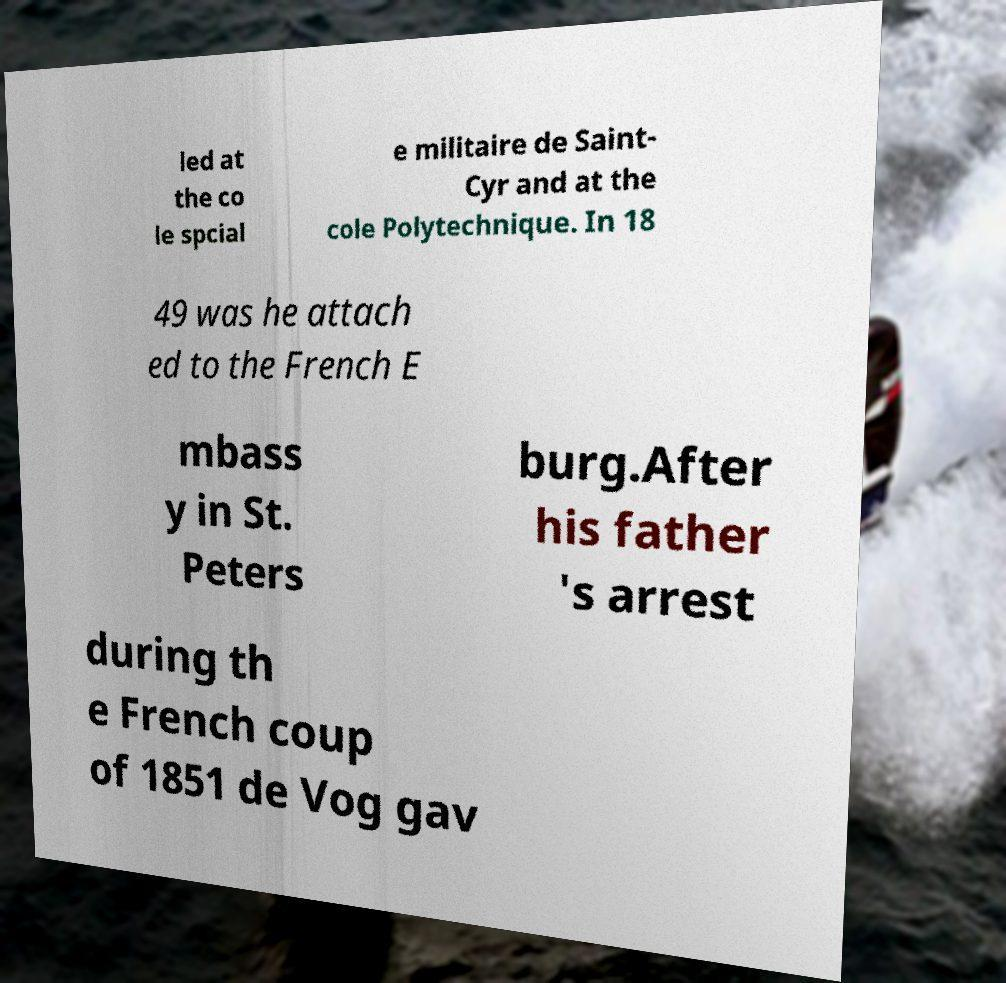Please read and relay the text visible in this image. What does it say? led at the co le spcial e militaire de Saint- Cyr and at the cole Polytechnique. In 18 49 was he attach ed to the French E mbass y in St. Peters burg.After his father 's arrest during th e French coup of 1851 de Vog gav 